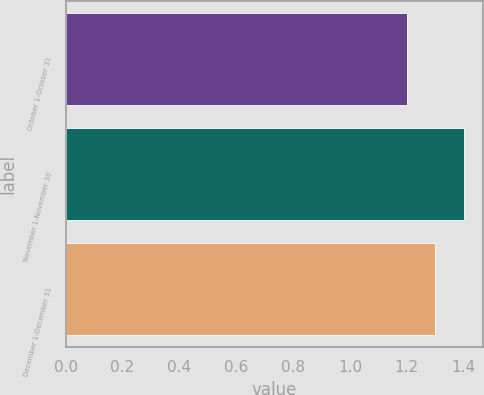<chart> <loc_0><loc_0><loc_500><loc_500><bar_chart><fcel>October 1-October 31<fcel>November 1-November 30<fcel>December 1-December 31<nl><fcel>1.2<fcel>1.4<fcel>1.3<nl></chart> 